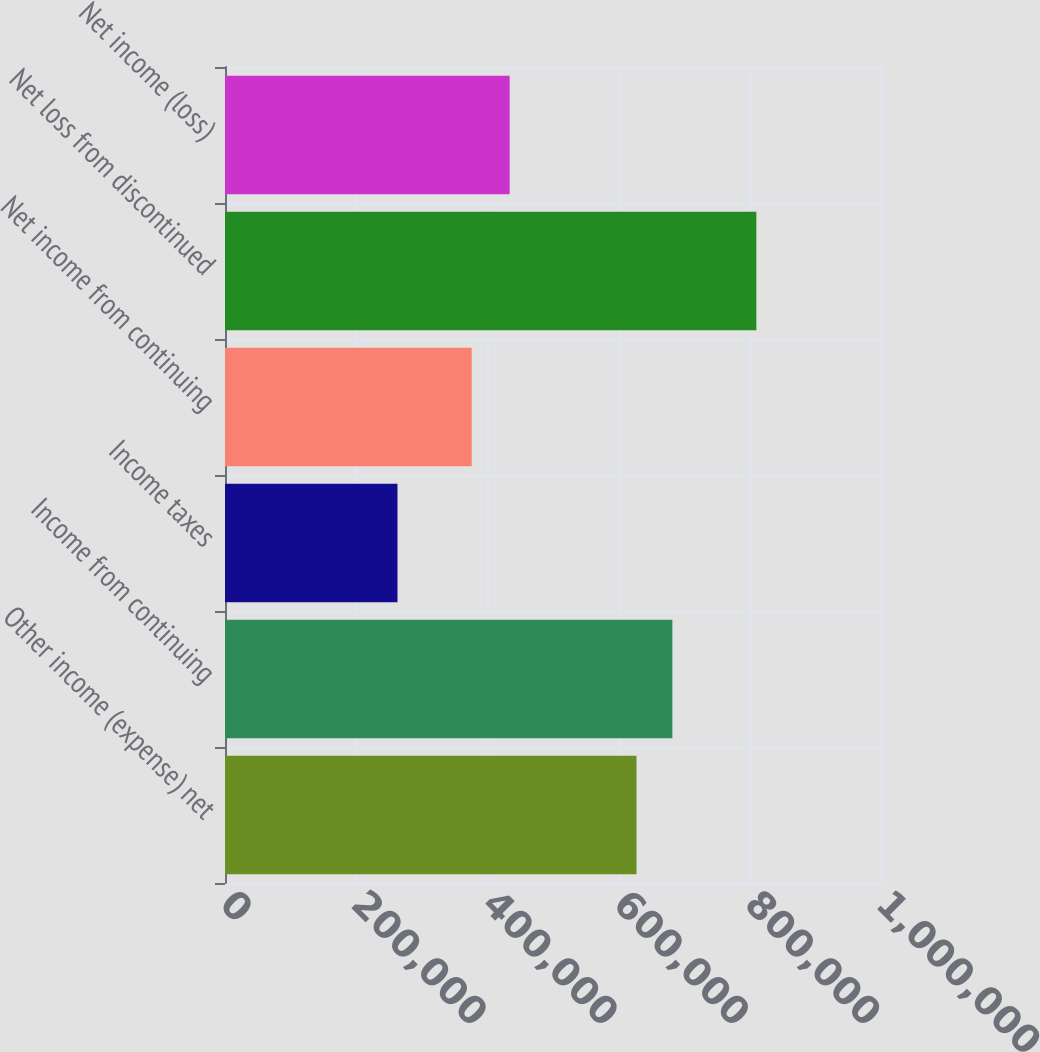Convert chart. <chart><loc_0><loc_0><loc_500><loc_500><bar_chart><fcel>Other income (expense) net<fcel>Income from continuing<fcel>Income taxes<fcel>Net income from continuing<fcel>Net loss from discontinued<fcel>Net income (loss)<nl><fcel>627261<fcel>681972<fcel>262904<fcel>376056<fcel>810019<fcel>433963<nl></chart> 